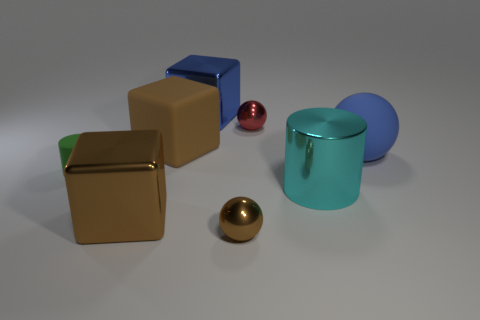Is the number of small metallic objects that are to the left of the tiny red thing greater than the number of brown metallic cubes?
Provide a succinct answer. No. What color is the big metallic object to the right of the thing that is behind the red metal ball?
Your answer should be very brief. Cyan. How many things are either small things that are in front of the red ball or small spheres that are behind the large brown metal object?
Make the answer very short. 3. The large metallic cylinder has what color?
Offer a terse response. Cyan. What number of big blue blocks have the same material as the tiny green cylinder?
Keep it short and to the point. 0. Is the number of small brown balls greater than the number of large green cubes?
Provide a succinct answer. Yes. What number of rubber things are behind the ball behind the large blue sphere?
Provide a succinct answer. 0. What number of things are either brown things behind the small brown metallic ball or big cyan cylinders?
Provide a succinct answer. 3. Are there any brown shiny things of the same shape as the red shiny thing?
Provide a succinct answer. Yes. What is the shape of the tiny thing right of the small metal thing that is in front of the small red metallic sphere?
Offer a very short reply. Sphere. 